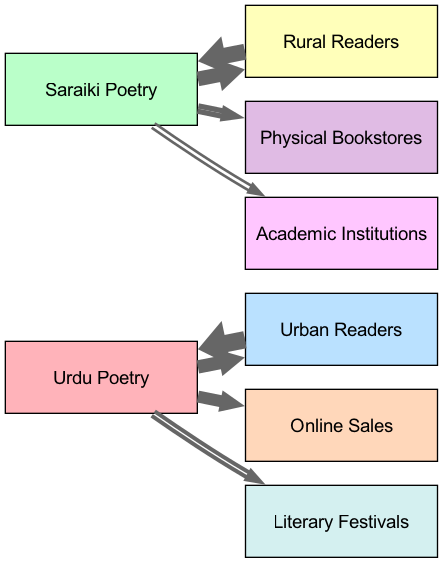What percentage of Urdu poetry readers are urban? The diagram shows a link from Urdu Poetry to Urban Readers with a value of 60, indicating that 60% of the readership for Urdu poetry is urban.
Answer: 60% How many readers prefer Saraiki poetry from rural areas? The link from Rural Readers to Saraiki Poetry contains a value of 80, meaning that 80 readers prefer Saraiki poetry from rural areas.
Answer: 80 What is the sales preference for Urdu poetry in online sales? The link from Urdu Poetry to Online Sales has a value of 50, indicating that 50 units of Urdu poetry are sold online.
Answer: 50 Where do most Saraiki poetry sales occur? The diagram indicates that the main sales channel for Saraiki poetry is Physical Bookstores with a value of 40.
Answer: Physical Bookstores Which type of readers shows a higher preference for Urdu poetry? The diagram shows a higher value for Urban Readers, who show a readership of 90 for Urdu poetry.
Answer: Urban Readers In terms of academic interest, which poetry type is favored? The link from Saraiki Poetry to Academic Institutions is 20 while Urdu Poetry has no direct link there, indicating that Saraiki poetry sees more academic interest.
Answer: Saraiki Poetry What is the relationship between urban readers and sales of Urdu poetry? The diagram shows a direct link from Urban Readers to Urdu Poetry with a significant value of 90, influencing the sales through Online Channels as well.
Answer: Strong positive relationship Which poetry type has more representation in literary festivals? Urdu Poetry has a link to Literary Festivals with a value of 30, indicating its presence in such events.
Answer: Urdu Poetry How do rural readers compare to urban readers in their preferences for poetry? Rural Readers are linked strongly to Saraiki Poetry with a value of 80, while Urban Readers predominantly favor Urdu Poetry with a value of 90, showing differing preferences.
Answer: Different preferences 